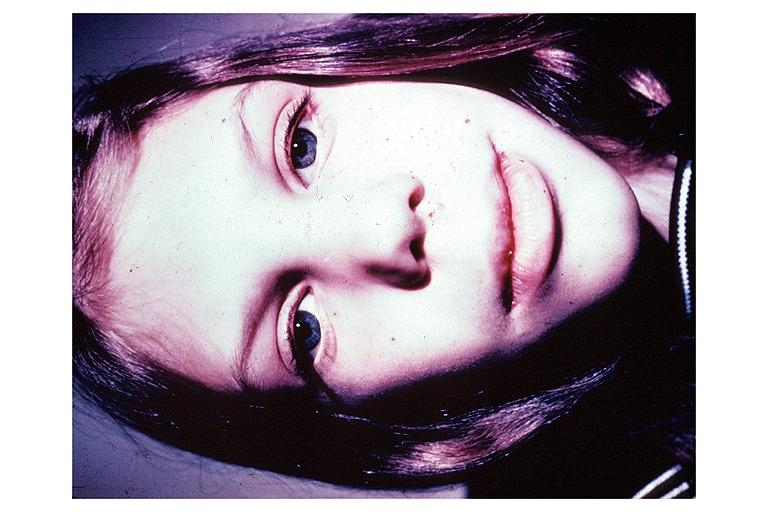what does this image show?
Answer the question using a single word or phrase. Multiple endocrine neoplasia type iib 